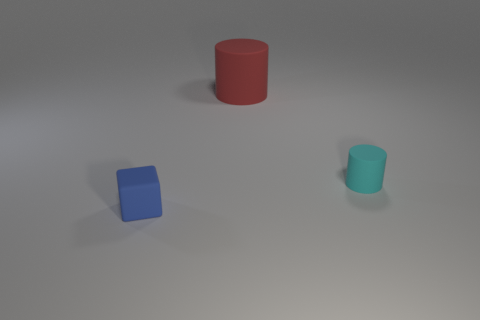Add 1 purple rubber balls. How many objects exist? 4 Subtract all cylinders. How many objects are left? 1 Add 2 large rubber cylinders. How many large rubber cylinders are left? 3 Add 3 tiny cyan cylinders. How many tiny cyan cylinders exist? 4 Subtract 0 purple cylinders. How many objects are left? 3 Subtract all cyan matte things. Subtract all cyan objects. How many objects are left? 1 